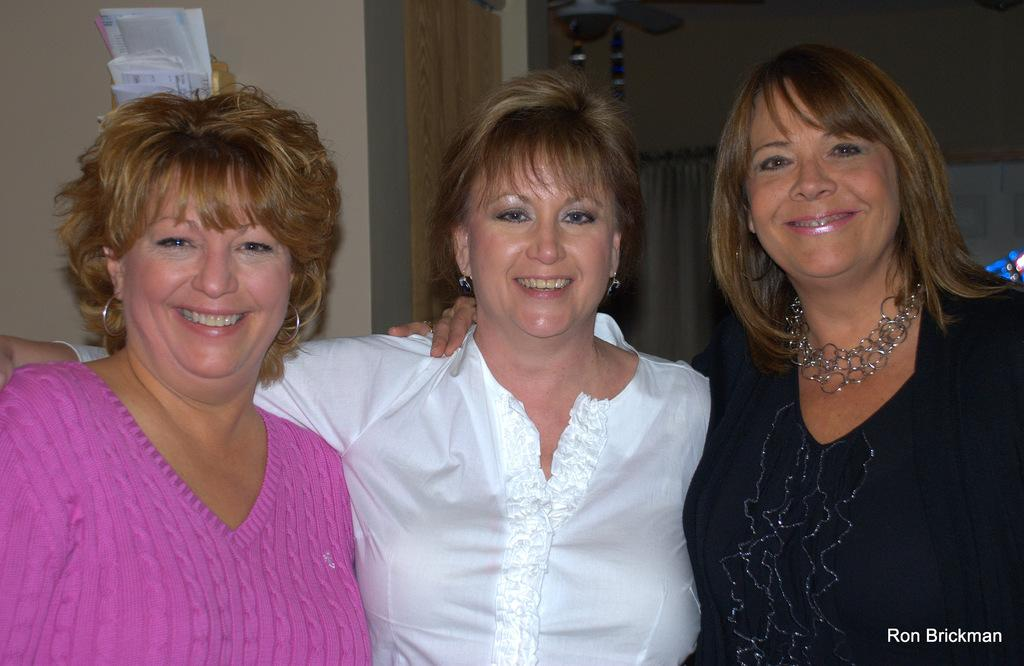How many women are present in the image? There are three women in the image. What is the facial expression of the women? The women are smiling. What objects can be seen in the image besides the women? There are papers visible in the image. What is the background of the image? There is a wall in the image, and curtains are visible in the background. What type of volleyball game is being played in the image? There is no volleyball game present in the image. What home appliance is visible in the image? There is no home appliance visible in the image. 